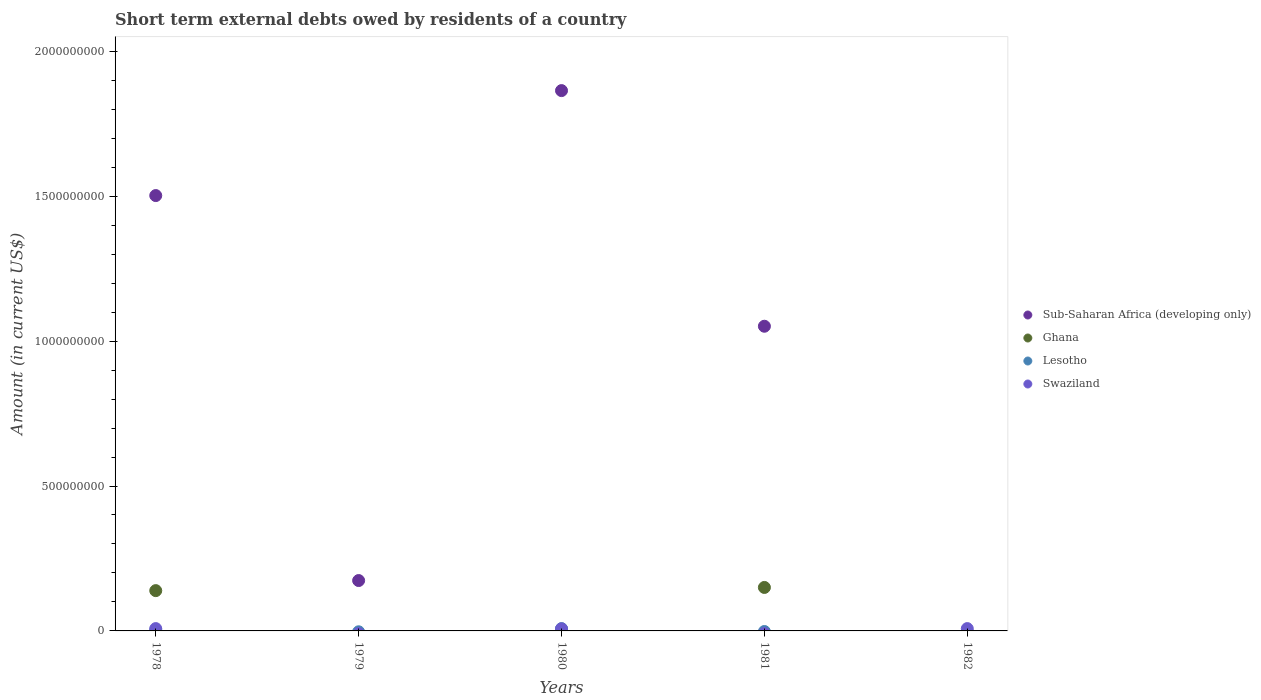How many different coloured dotlines are there?
Offer a terse response. 4. Is the number of dotlines equal to the number of legend labels?
Provide a short and direct response. No. What is the amount of short-term external debts owed by residents in Sub-Saharan Africa (developing only) in 1980?
Give a very brief answer. 1.86e+09. Across all years, what is the maximum amount of short-term external debts owed by residents in Swaziland?
Provide a short and direct response. 8.00e+06. Across all years, what is the minimum amount of short-term external debts owed by residents in Ghana?
Provide a short and direct response. 0. In which year was the amount of short-term external debts owed by residents in Sub-Saharan Africa (developing only) maximum?
Your response must be concise. 1980. What is the total amount of short-term external debts owed by residents in Ghana in the graph?
Offer a terse response. 2.89e+08. What is the difference between the amount of short-term external debts owed by residents in Sub-Saharan Africa (developing only) in 1978 and that in 1980?
Provide a short and direct response. -3.62e+08. What is the difference between the amount of short-term external debts owed by residents in Lesotho in 1979 and the amount of short-term external debts owed by residents in Swaziland in 1982?
Keep it short and to the point. -8.00e+06. What is the average amount of short-term external debts owed by residents in Sub-Saharan Africa (developing only) per year?
Your response must be concise. 9.18e+08. In the year 1978, what is the difference between the amount of short-term external debts owed by residents in Ghana and amount of short-term external debts owed by residents in Lesotho?
Provide a succinct answer. 1.36e+08. In how many years, is the amount of short-term external debts owed by residents in Swaziland greater than 1100000000 US$?
Provide a short and direct response. 0. What is the ratio of the amount of short-term external debts owed by residents in Sub-Saharan Africa (developing only) in 1978 to that in 1979?
Provide a succinct answer. 8.64. Is the amount of short-term external debts owed by residents in Swaziland in 1978 less than that in 1980?
Your answer should be compact. No. What is the difference between the highest and the second highest amount of short-term external debts owed by residents in Swaziland?
Make the answer very short. 0. What is the difference between the highest and the lowest amount of short-term external debts owed by residents in Sub-Saharan Africa (developing only)?
Your answer should be compact. 1.86e+09. In how many years, is the amount of short-term external debts owed by residents in Swaziland greater than the average amount of short-term external debts owed by residents in Swaziland taken over all years?
Offer a terse response. 3. Is the amount of short-term external debts owed by residents in Lesotho strictly less than the amount of short-term external debts owed by residents in Sub-Saharan Africa (developing only) over the years?
Provide a short and direct response. No. Are the values on the major ticks of Y-axis written in scientific E-notation?
Give a very brief answer. No. How are the legend labels stacked?
Provide a short and direct response. Vertical. What is the title of the graph?
Give a very brief answer. Short term external debts owed by residents of a country. Does "Antigua and Barbuda" appear as one of the legend labels in the graph?
Make the answer very short. No. What is the label or title of the Y-axis?
Provide a short and direct response. Amount (in current US$). What is the Amount (in current US$) of Sub-Saharan Africa (developing only) in 1978?
Offer a terse response. 1.50e+09. What is the Amount (in current US$) of Ghana in 1978?
Your answer should be compact. 1.39e+08. What is the Amount (in current US$) in Sub-Saharan Africa (developing only) in 1979?
Provide a succinct answer. 1.74e+08. What is the Amount (in current US$) in Lesotho in 1979?
Give a very brief answer. 0. What is the Amount (in current US$) in Sub-Saharan Africa (developing only) in 1980?
Offer a very short reply. 1.86e+09. What is the Amount (in current US$) of Ghana in 1980?
Provide a succinct answer. 0. What is the Amount (in current US$) in Lesotho in 1980?
Provide a succinct answer. 8.00e+06. What is the Amount (in current US$) in Sub-Saharan Africa (developing only) in 1981?
Give a very brief answer. 1.05e+09. What is the Amount (in current US$) in Ghana in 1981?
Provide a short and direct response. 1.50e+08. What is the Amount (in current US$) in Lesotho in 1981?
Offer a terse response. 0. What is the Amount (in current US$) in Sub-Saharan Africa (developing only) in 1982?
Give a very brief answer. 0. What is the Amount (in current US$) in Lesotho in 1982?
Ensure brevity in your answer.  0. What is the Amount (in current US$) of Swaziland in 1982?
Your answer should be compact. 8.00e+06. Across all years, what is the maximum Amount (in current US$) in Sub-Saharan Africa (developing only)?
Your response must be concise. 1.86e+09. Across all years, what is the maximum Amount (in current US$) of Ghana?
Your response must be concise. 1.50e+08. Across all years, what is the minimum Amount (in current US$) of Sub-Saharan Africa (developing only)?
Your response must be concise. 0. What is the total Amount (in current US$) of Sub-Saharan Africa (developing only) in the graph?
Offer a very short reply. 4.59e+09. What is the total Amount (in current US$) of Ghana in the graph?
Provide a succinct answer. 2.89e+08. What is the total Amount (in current US$) in Lesotho in the graph?
Your answer should be compact. 1.10e+07. What is the total Amount (in current US$) of Swaziland in the graph?
Provide a short and direct response. 2.30e+07. What is the difference between the Amount (in current US$) of Sub-Saharan Africa (developing only) in 1978 and that in 1979?
Provide a succinct answer. 1.33e+09. What is the difference between the Amount (in current US$) in Sub-Saharan Africa (developing only) in 1978 and that in 1980?
Keep it short and to the point. -3.62e+08. What is the difference between the Amount (in current US$) of Lesotho in 1978 and that in 1980?
Make the answer very short. -5.00e+06. What is the difference between the Amount (in current US$) in Sub-Saharan Africa (developing only) in 1978 and that in 1981?
Provide a succinct answer. 4.51e+08. What is the difference between the Amount (in current US$) in Ghana in 1978 and that in 1981?
Your answer should be compact. -1.10e+07. What is the difference between the Amount (in current US$) in Sub-Saharan Africa (developing only) in 1979 and that in 1980?
Offer a very short reply. -1.69e+09. What is the difference between the Amount (in current US$) in Sub-Saharan Africa (developing only) in 1979 and that in 1981?
Keep it short and to the point. -8.77e+08. What is the difference between the Amount (in current US$) of Sub-Saharan Africa (developing only) in 1980 and that in 1981?
Offer a very short reply. 8.13e+08. What is the difference between the Amount (in current US$) of Swaziland in 1980 and that in 1982?
Your answer should be very brief. -1.00e+06. What is the difference between the Amount (in current US$) in Sub-Saharan Africa (developing only) in 1978 and the Amount (in current US$) in Lesotho in 1980?
Your response must be concise. 1.49e+09. What is the difference between the Amount (in current US$) in Sub-Saharan Africa (developing only) in 1978 and the Amount (in current US$) in Swaziland in 1980?
Provide a succinct answer. 1.50e+09. What is the difference between the Amount (in current US$) of Ghana in 1978 and the Amount (in current US$) of Lesotho in 1980?
Your response must be concise. 1.31e+08. What is the difference between the Amount (in current US$) of Ghana in 1978 and the Amount (in current US$) of Swaziland in 1980?
Keep it short and to the point. 1.32e+08. What is the difference between the Amount (in current US$) in Lesotho in 1978 and the Amount (in current US$) in Swaziland in 1980?
Your answer should be compact. -4.00e+06. What is the difference between the Amount (in current US$) of Sub-Saharan Africa (developing only) in 1978 and the Amount (in current US$) of Ghana in 1981?
Your answer should be compact. 1.35e+09. What is the difference between the Amount (in current US$) of Sub-Saharan Africa (developing only) in 1978 and the Amount (in current US$) of Swaziland in 1982?
Give a very brief answer. 1.49e+09. What is the difference between the Amount (in current US$) in Ghana in 1978 and the Amount (in current US$) in Swaziland in 1982?
Your response must be concise. 1.31e+08. What is the difference between the Amount (in current US$) of Lesotho in 1978 and the Amount (in current US$) of Swaziland in 1982?
Give a very brief answer. -5.00e+06. What is the difference between the Amount (in current US$) of Sub-Saharan Africa (developing only) in 1979 and the Amount (in current US$) of Lesotho in 1980?
Offer a very short reply. 1.66e+08. What is the difference between the Amount (in current US$) in Sub-Saharan Africa (developing only) in 1979 and the Amount (in current US$) in Swaziland in 1980?
Ensure brevity in your answer.  1.67e+08. What is the difference between the Amount (in current US$) in Sub-Saharan Africa (developing only) in 1979 and the Amount (in current US$) in Ghana in 1981?
Your answer should be very brief. 2.38e+07. What is the difference between the Amount (in current US$) of Sub-Saharan Africa (developing only) in 1979 and the Amount (in current US$) of Swaziland in 1982?
Your answer should be compact. 1.66e+08. What is the difference between the Amount (in current US$) of Sub-Saharan Africa (developing only) in 1980 and the Amount (in current US$) of Ghana in 1981?
Provide a short and direct response. 1.71e+09. What is the difference between the Amount (in current US$) in Sub-Saharan Africa (developing only) in 1980 and the Amount (in current US$) in Swaziland in 1982?
Offer a very short reply. 1.86e+09. What is the difference between the Amount (in current US$) in Lesotho in 1980 and the Amount (in current US$) in Swaziland in 1982?
Provide a short and direct response. 0. What is the difference between the Amount (in current US$) in Sub-Saharan Africa (developing only) in 1981 and the Amount (in current US$) in Swaziland in 1982?
Keep it short and to the point. 1.04e+09. What is the difference between the Amount (in current US$) of Ghana in 1981 and the Amount (in current US$) of Swaziland in 1982?
Ensure brevity in your answer.  1.42e+08. What is the average Amount (in current US$) of Sub-Saharan Africa (developing only) per year?
Your answer should be compact. 9.18e+08. What is the average Amount (in current US$) in Ghana per year?
Offer a very short reply. 5.78e+07. What is the average Amount (in current US$) of Lesotho per year?
Your response must be concise. 2.20e+06. What is the average Amount (in current US$) of Swaziland per year?
Make the answer very short. 4.60e+06. In the year 1978, what is the difference between the Amount (in current US$) of Sub-Saharan Africa (developing only) and Amount (in current US$) of Ghana?
Your response must be concise. 1.36e+09. In the year 1978, what is the difference between the Amount (in current US$) in Sub-Saharan Africa (developing only) and Amount (in current US$) in Lesotho?
Your answer should be compact. 1.50e+09. In the year 1978, what is the difference between the Amount (in current US$) of Sub-Saharan Africa (developing only) and Amount (in current US$) of Swaziland?
Offer a terse response. 1.49e+09. In the year 1978, what is the difference between the Amount (in current US$) of Ghana and Amount (in current US$) of Lesotho?
Offer a terse response. 1.36e+08. In the year 1978, what is the difference between the Amount (in current US$) of Ghana and Amount (in current US$) of Swaziland?
Your answer should be very brief. 1.31e+08. In the year 1978, what is the difference between the Amount (in current US$) of Lesotho and Amount (in current US$) of Swaziland?
Give a very brief answer. -5.00e+06. In the year 1980, what is the difference between the Amount (in current US$) of Sub-Saharan Africa (developing only) and Amount (in current US$) of Lesotho?
Your answer should be compact. 1.86e+09. In the year 1980, what is the difference between the Amount (in current US$) in Sub-Saharan Africa (developing only) and Amount (in current US$) in Swaziland?
Provide a short and direct response. 1.86e+09. In the year 1980, what is the difference between the Amount (in current US$) in Lesotho and Amount (in current US$) in Swaziland?
Offer a very short reply. 1.00e+06. In the year 1981, what is the difference between the Amount (in current US$) in Sub-Saharan Africa (developing only) and Amount (in current US$) in Ghana?
Make the answer very short. 9.01e+08. What is the ratio of the Amount (in current US$) in Sub-Saharan Africa (developing only) in 1978 to that in 1979?
Your answer should be very brief. 8.64. What is the ratio of the Amount (in current US$) of Sub-Saharan Africa (developing only) in 1978 to that in 1980?
Your response must be concise. 0.81. What is the ratio of the Amount (in current US$) in Swaziland in 1978 to that in 1980?
Ensure brevity in your answer.  1.14. What is the ratio of the Amount (in current US$) in Sub-Saharan Africa (developing only) in 1978 to that in 1981?
Keep it short and to the point. 1.43. What is the ratio of the Amount (in current US$) in Ghana in 1978 to that in 1981?
Keep it short and to the point. 0.93. What is the ratio of the Amount (in current US$) of Sub-Saharan Africa (developing only) in 1979 to that in 1980?
Provide a short and direct response. 0.09. What is the ratio of the Amount (in current US$) in Sub-Saharan Africa (developing only) in 1979 to that in 1981?
Ensure brevity in your answer.  0.17. What is the ratio of the Amount (in current US$) of Sub-Saharan Africa (developing only) in 1980 to that in 1981?
Make the answer very short. 1.77. What is the ratio of the Amount (in current US$) of Swaziland in 1980 to that in 1982?
Keep it short and to the point. 0.88. What is the difference between the highest and the second highest Amount (in current US$) of Sub-Saharan Africa (developing only)?
Offer a terse response. 3.62e+08. What is the difference between the highest and the lowest Amount (in current US$) of Sub-Saharan Africa (developing only)?
Provide a succinct answer. 1.86e+09. What is the difference between the highest and the lowest Amount (in current US$) of Ghana?
Offer a very short reply. 1.50e+08. What is the difference between the highest and the lowest Amount (in current US$) in Lesotho?
Give a very brief answer. 8.00e+06. 